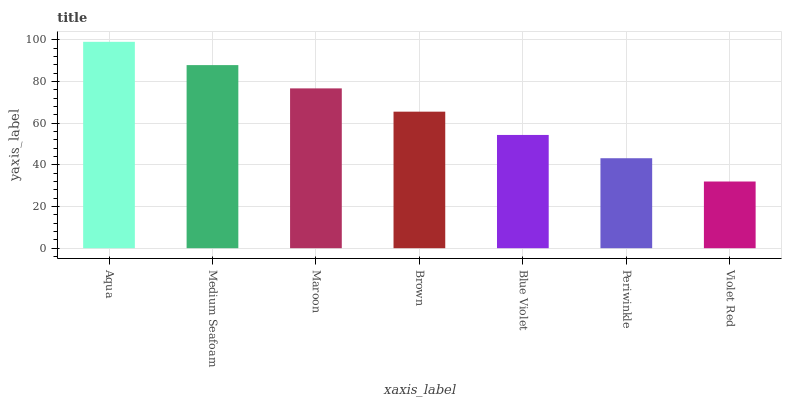Is Violet Red the minimum?
Answer yes or no. Yes. Is Aqua the maximum?
Answer yes or no. Yes. Is Medium Seafoam the minimum?
Answer yes or no. No. Is Medium Seafoam the maximum?
Answer yes or no. No. Is Aqua greater than Medium Seafoam?
Answer yes or no. Yes. Is Medium Seafoam less than Aqua?
Answer yes or no. Yes. Is Medium Seafoam greater than Aqua?
Answer yes or no. No. Is Aqua less than Medium Seafoam?
Answer yes or no. No. Is Brown the high median?
Answer yes or no. Yes. Is Brown the low median?
Answer yes or no. Yes. Is Violet Red the high median?
Answer yes or no. No. Is Aqua the low median?
Answer yes or no. No. 